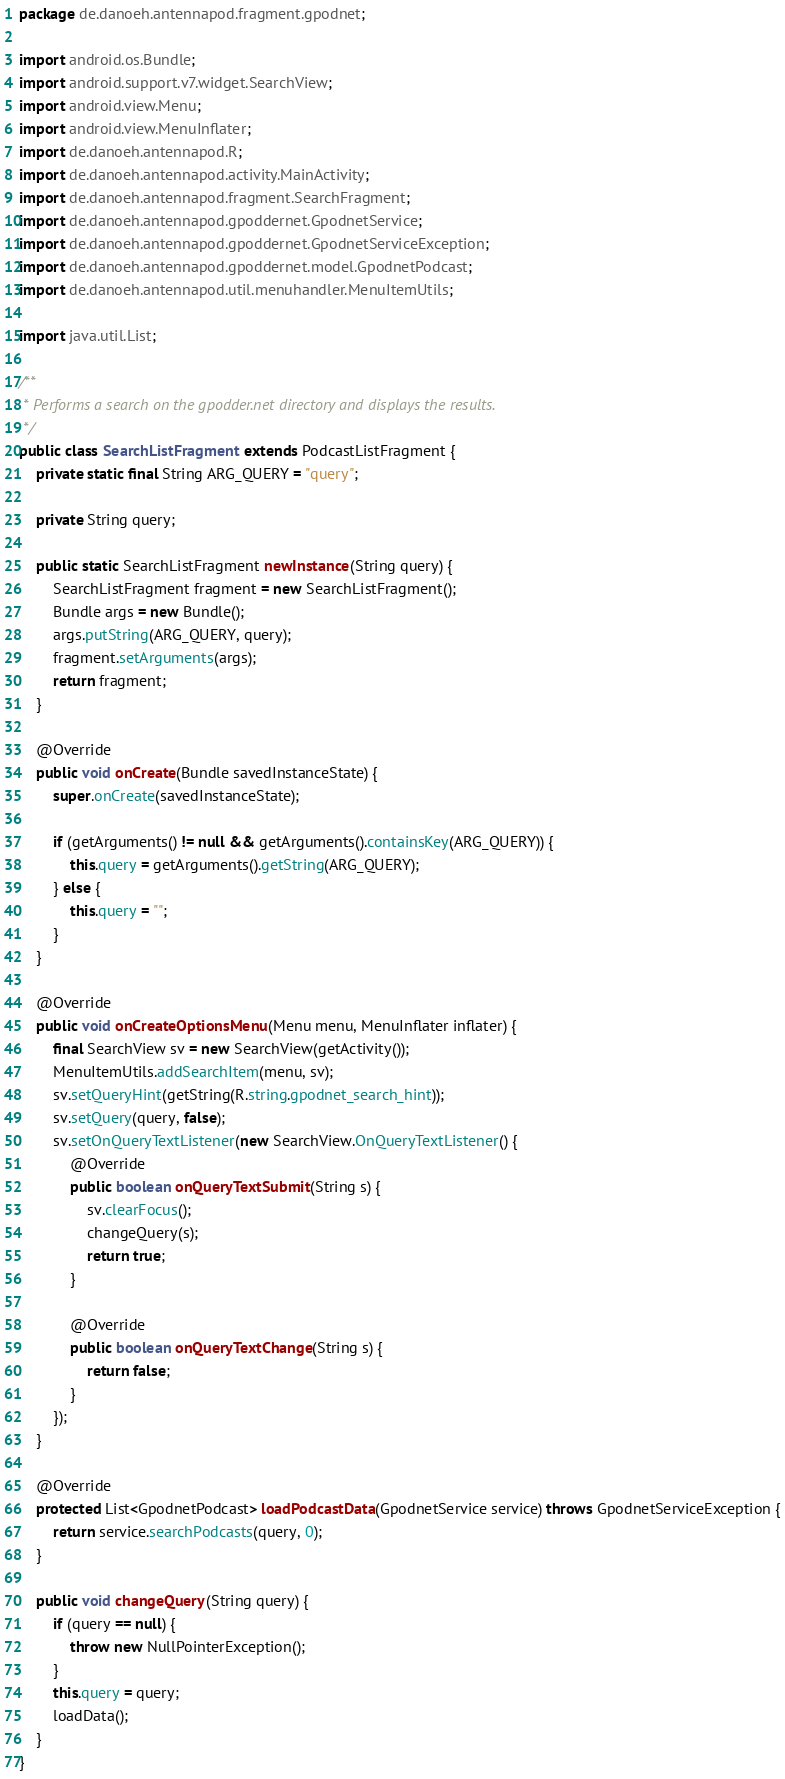<code> <loc_0><loc_0><loc_500><loc_500><_Java_>package de.danoeh.antennapod.fragment.gpodnet;

import android.os.Bundle;
import android.support.v7.widget.SearchView;
import android.view.Menu;
import android.view.MenuInflater;
import de.danoeh.antennapod.R;
import de.danoeh.antennapod.activity.MainActivity;
import de.danoeh.antennapod.fragment.SearchFragment;
import de.danoeh.antennapod.gpoddernet.GpodnetService;
import de.danoeh.antennapod.gpoddernet.GpodnetServiceException;
import de.danoeh.antennapod.gpoddernet.model.GpodnetPodcast;
import de.danoeh.antennapod.util.menuhandler.MenuItemUtils;

import java.util.List;

/**
 * Performs a search on the gpodder.net directory and displays the results.
 */
public class SearchListFragment extends PodcastListFragment {
    private static final String ARG_QUERY = "query";

    private String query;

    public static SearchListFragment newInstance(String query) {
        SearchListFragment fragment = new SearchListFragment();
        Bundle args = new Bundle();
        args.putString(ARG_QUERY, query);
        fragment.setArguments(args);
        return fragment;
    }

    @Override
    public void onCreate(Bundle savedInstanceState) {
        super.onCreate(savedInstanceState);

        if (getArguments() != null && getArguments().containsKey(ARG_QUERY)) {
            this.query = getArguments().getString(ARG_QUERY);
        } else {
            this.query = "";
        }
    }

    @Override
    public void onCreateOptionsMenu(Menu menu, MenuInflater inflater) {
        final SearchView sv = new SearchView(getActivity());
        MenuItemUtils.addSearchItem(menu, sv);
        sv.setQueryHint(getString(R.string.gpodnet_search_hint));
        sv.setQuery(query, false);
        sv.setOnQueryTextListener(new SearchView.OnQueryTextListener() {
            @Override
            public boolean onQueryTextSubmit(String s) {
                sv.clearFocus();
                changeQuery(s);
                return true;
            }

            @Override
            public boolean onQueryTextChange(String s) {
                return false;
            }
        });
    }

    @Override
    protected List<GpodnetPodcast> loadPodcastData(GpodnetService service) throws GpodnetServiceException {
        return service.searchPodcasts(query, 0);
    }

    public void changeQuery(String query) {
        if (query == null) {
            throw new NullPointerException();
        }
        this.query = query;
        loadData();
    }
}
</code> 